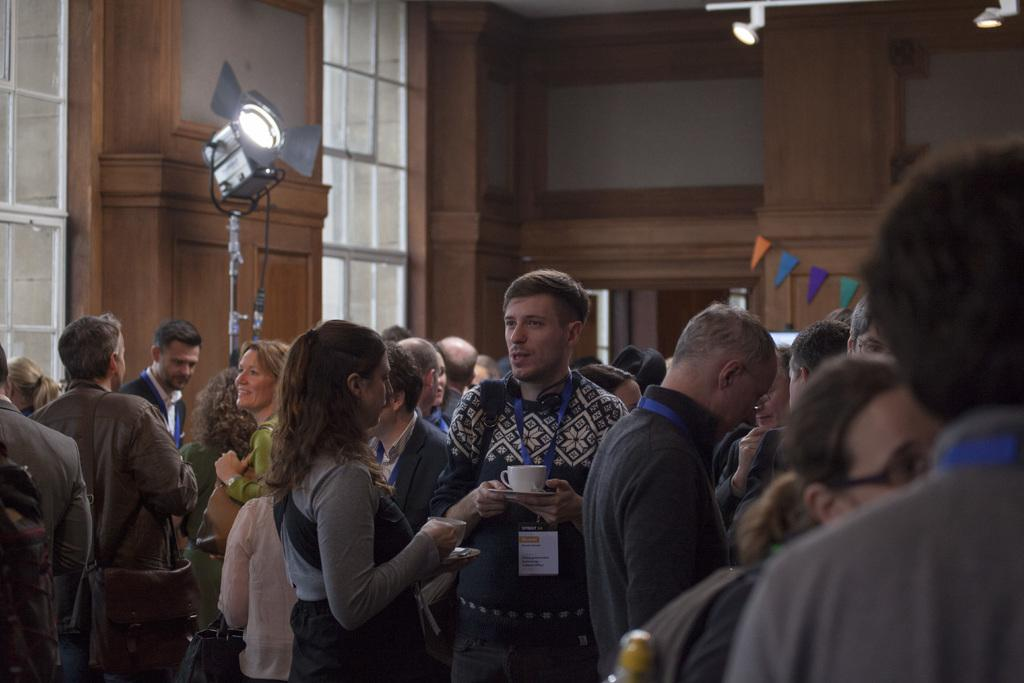What type of objects can be seen in the image related to serving beverages? There are cups and saucers in the image. What items are present in the image that might be used for identification purposes? There are ID cards in the image. What type of bags can be seen in the image? There are bags in the image. What object related to vision can be seen in the image? There is a spectacle in the image. What type of decorative items are present in the image? There are decorative flags in the image. What architectural feature is visible in the image? There are windows in the image. What type of vertical structure is present in the image? There is a pole in the image. What type of lighting is visible in the image? There are lights in the image. Can you describe the group of people in the image? There is a group of people standing in the image. How much does the drop of water weigh in the image? There is no drop of water present in the image. What type of request can be seen being made by the people in the image? There is no request being made by the people in the image. 